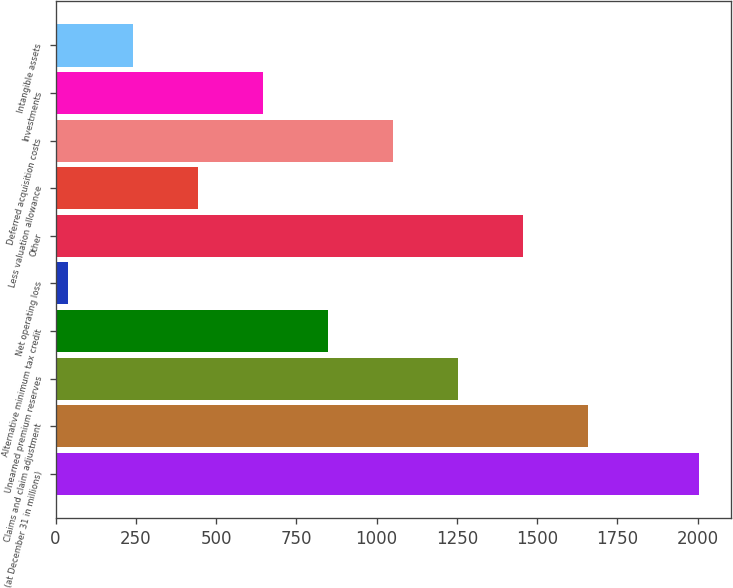Convert chart to OTSL. <chart><loc_0><loc_0><loc_500><loc_500><bar_chart><fcel>(at December 31 in millions)<fcel>Claims and claim adjustment<fcel>Unearned premium reserves<fcel>Alternative minimum tax credit<fcel>Net operating loss<fcel>Other<fcel>Less valuation allowance<fcel>Deferred acquisition costs<fcel>Investments<fcel>Intangible assets<nl><fcel>2005<fcel>1657.6<fcel>1253.2<fcel>848.8<fcel>40<fcel>1455.4<fcel>444.4<fcel>1051<fcel>646.6<fcel>242.2<nl></chart> 